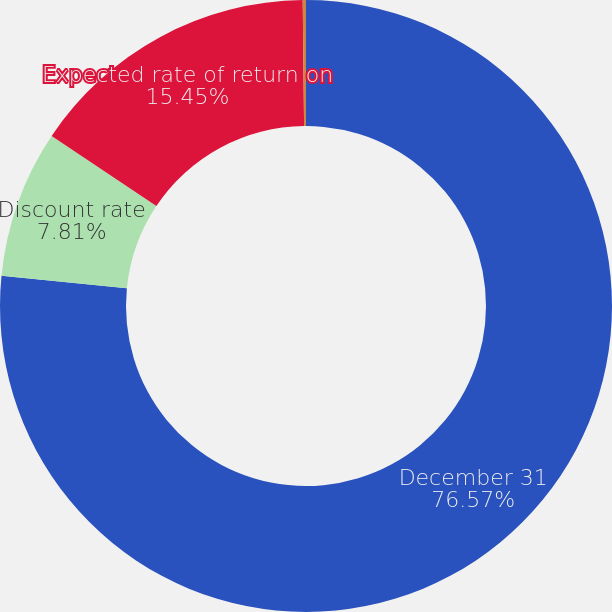Convert chart. <chart><loc_0><loc_0><loc_500><loc_500><pie_chart><fcel>December 31<fcel>Discount rate<fcel>Expected rate of return on<fcel>Salary growth rate<nl><fcel>76.57%<fcel>7.81%<fcel>15.45%<fcel>0.17%<nl></chart> 